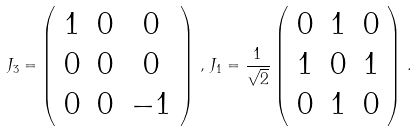Convert formula to latex. <formula><loc_0><loc_0><loc_500><loc_500>J _ { 3 } = \left ( \begin{array} { c c c } 1 & 0 & 0 \\ 0 & 0 & 0 \\ 0 & 0 & - 1 \end{array} \right ) \, , \, J _ { 1 } = \frac { 1 } { \sqrt { 2 } } \left ( \begin{array} { c c c } 0 & 1 & 0 \\ 1 & 0 & 1 \\ 0 & 1 & 0 \end{array} \right ) \, .</formula> 